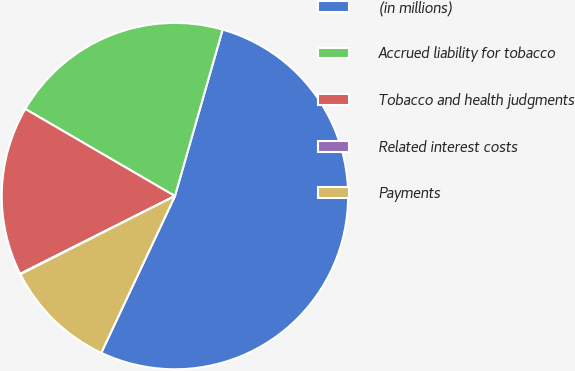Convert chart. <chart><loc_0><loc_0><loc_500><loc_500><pie_chart><fcel>(in millions)<fcel>Accrued liability for tobacco<fcel>Tobacco and health judgments<fcel>Related interest costs<fcel>Payments<nl><fcel>52.55%<fcel>21.05%<fcel>15.8%<fcel>0.05%<fcel>10.55%<nl></chart> 